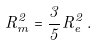<formula> <loc_0><loc_0><loc_500><loc_500>R _ { m } ^ { 2 } = \frac { 3 } { 5 } R _ { e } ^ { 2 } \, .</formula> 